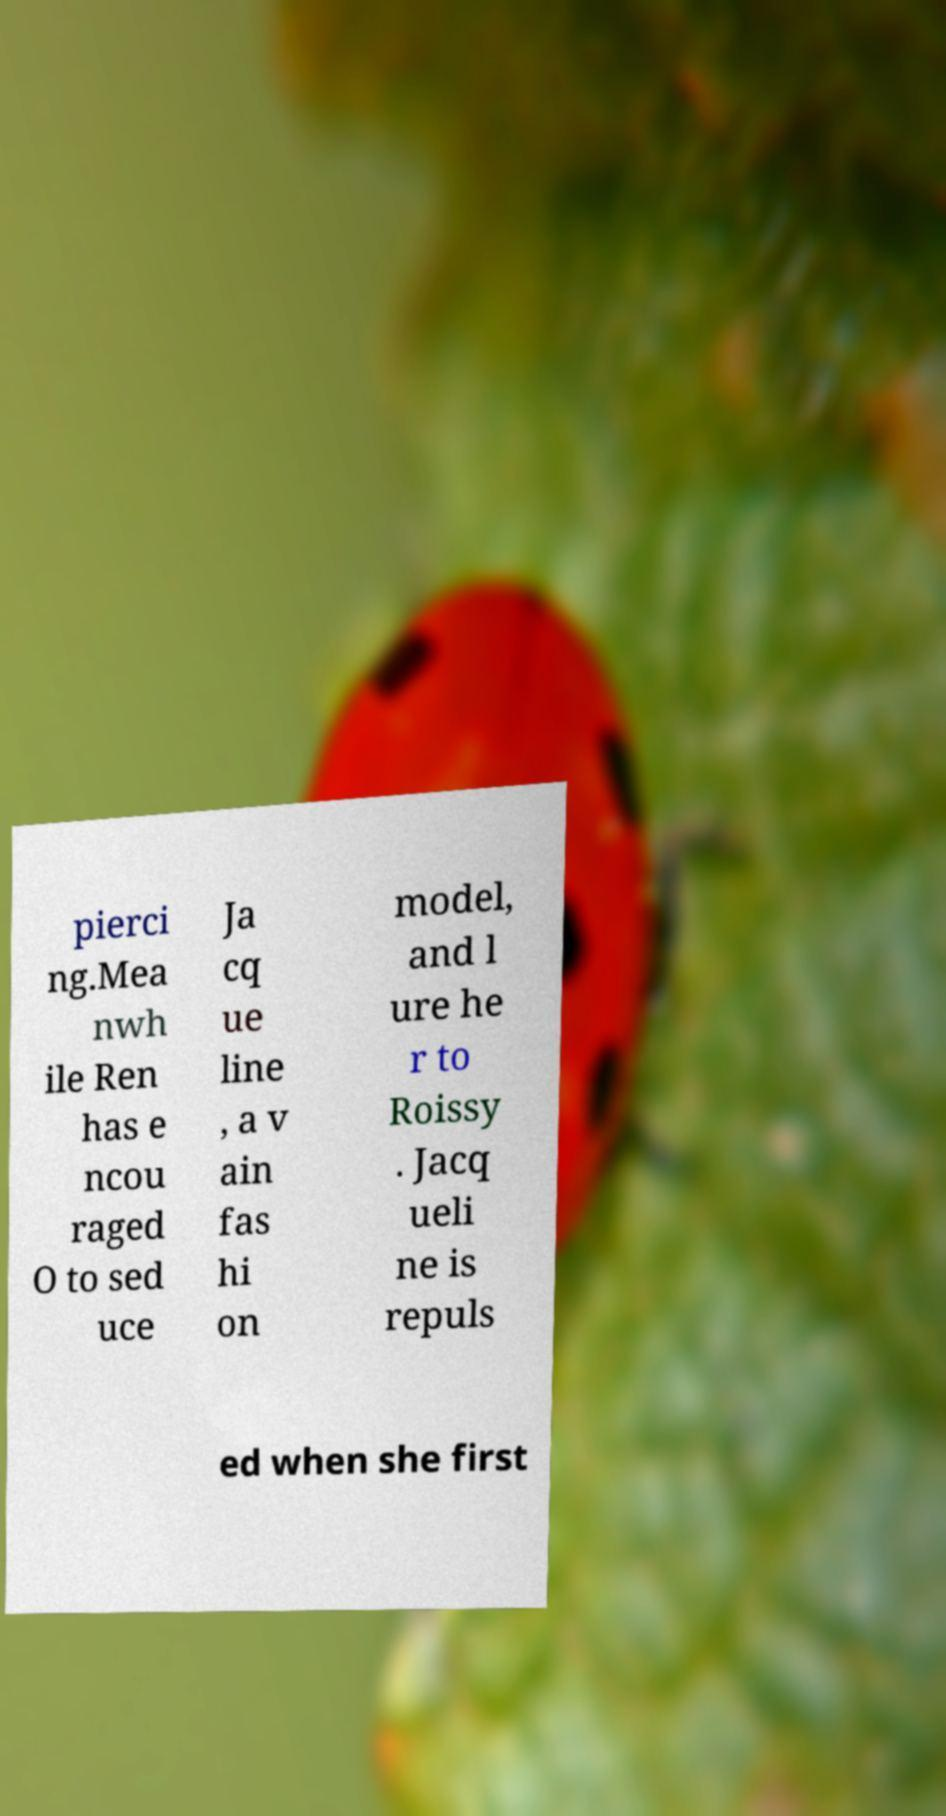Can you accurately transcribe the text from the provided image for me? pierci ng.Mea nwh ile Ren has e ncou raged O to sed uce Ja cq ue line , a v ain fas hi on model, and l ure he r to Roissy . Jacq ueli ne is repuls ed when she first 